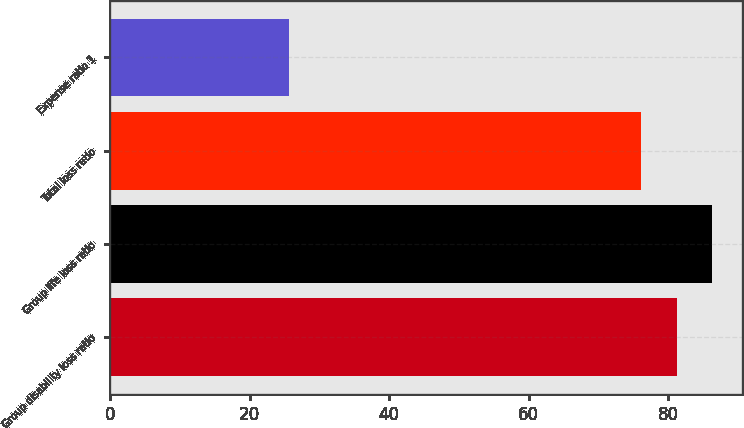Convert chart to OTSL. <chart><loc_0><loc_0><loc_500><loc_500><bar_chart><fcel>Group disability loss ratio<fcel>Group life loss ratio<fcel>Total loss ratio<fcel>Expense ratio 1<nl><fcel>81.2<fcel>86.3<fcel>76.1<fcel>25.7<nl></chart> 